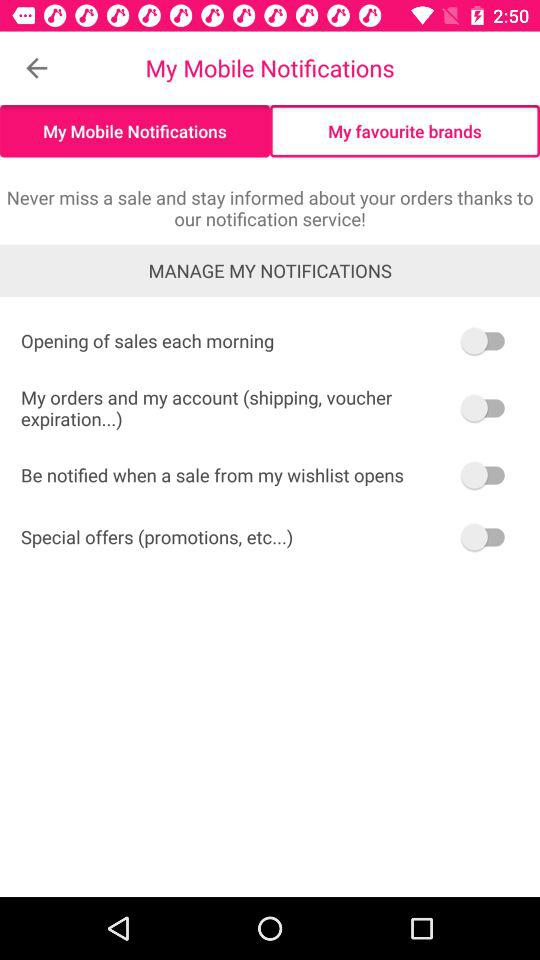Which tab has been selected? The tab "My Mobile Notifications" has been selected. 